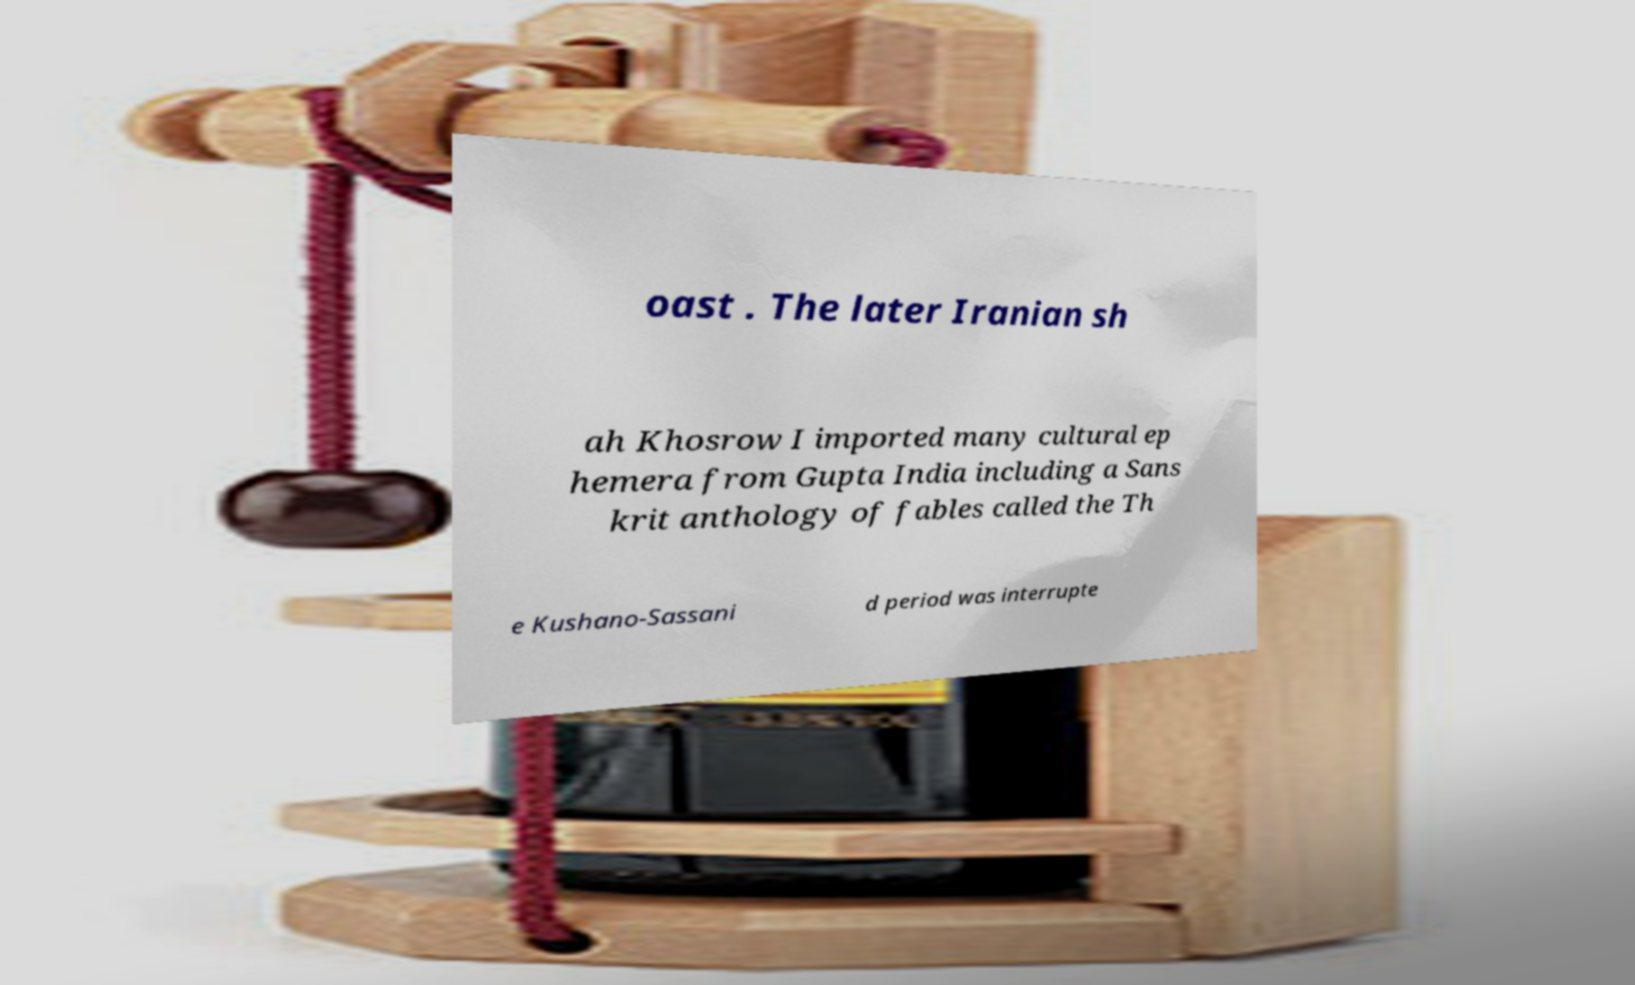Can you accurately transcribe the text from the provided image for me? oast . The later Iranian sh ah Khosrow I imported many cultural ep hemera from Gupta India including a Sans krit anthology of fables called the Th e Kushano-Sassani d period was interrupte 